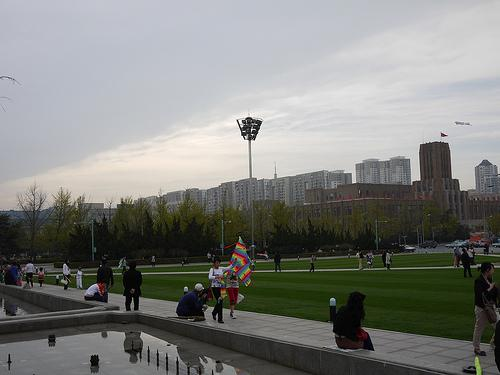Question: where is the skyline?
Choices:
A. Above the city.
B. Above the ocean.
C. Beyond the park and trees.
D. Above the mountain.
Answer with the letter. Answer: C Question: what is rainbow colored?
Choices:
A. Kite.
B. Flag.
C. Car.
D. A kite, a woman is carrying.
Answer with the letter. Answer: D 